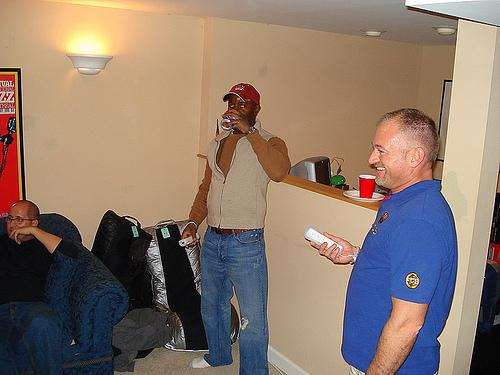What happen to the eyes of the man who is drinking? Please explain your reasoning. light reflection. The lights and camera can change eyes in photos 